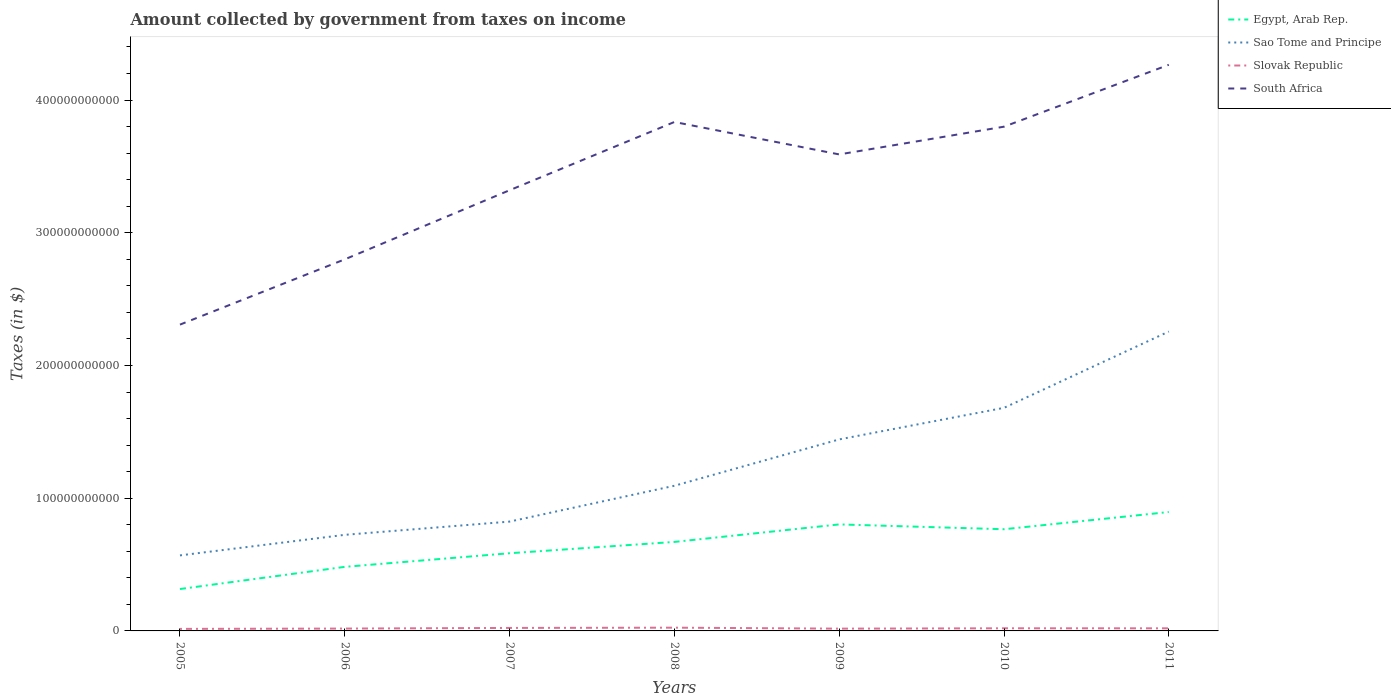Across all years, what is the maximum amount collected by government from taxes on income in South Africa?
Provide a succinct answer. 2.31e+11. In which year was the amount collected by government from taxes on income in Slovak Republic maximum?
Your answer should be compact. 2005. What is the total amount collected by government from taxes on income in South Africa in the graph?
Keep it short and to the point. -2.09e+1. What is the difference between the highest and the second highest amount collected by government from taxes on income in Egypt, Arab Rep.?
Your response must be concise. 5.80e+1. What is the difference between the highest and the lowest amount collected by government from taxes on income in Slovak Republic?
Offer a terse response. 4. Is the amount collected by government from taxes on income in Slovak Republic strictly greater than the amount collected by government from taxes on income in Sao Tome and Principe over the years?
Offer a terse response. Yes. How many lines are there?
Ensure brevity in your answer.  4. How many years are there in the graph?
Your answer should be very brief. 7. What is the difference between two consecutive major ticks on the Y-axis?
Offer a terse response. 1.00e+11. Are the values on the major ticks of Y-axis written in scientific E-notation?
Provide a short and direct response. No. Does the graph contain grids?
Your answer should be compact. No. Where does the legend appear in the graph?
Give a very brief answer. Top right. How many legend labels are there?
Your answer should be very brief. 4. How are the legend labels stacked?
Your answer should be very brief. Vertical. What is the title of the graph?
Offer a terse response. Amount collected by government from taxes on income. What is the label or title of the Y-axis?
Ensure brevity in your answer.  Taxes (in $). What is the Taxes (in $) of Egypt, Arab Rep. in 2005?
Offer a terse response. 3.16e+1. What is the Taxes (in $) of Sao Tome and Principe in 2005?
Your answer should be very brief. 5.69e+1. What is the Taxes (in $) of Slovak Republic in 2005?
Keep it short and to the point. 1.54e+09. What is the Taxes (in $) of South Africa in 2005?
Your answer should be compact. 2.31e+11. What is the Taxes (in $) of Egypt, Arab Rep. in 2006?
Offer a terse response. 4.83e+1. What is the Taxes (in $) in Sao Tome and Principe in 2006?
Keep it short and to the point. 7.24e+1. What is the Taxes (in $) of Slovak Republic in 2006?
Provide a succinct answer. 1.77e+09. What is the Taxes (in $) of South Africa in 2006?
Give a very brief answer. 2.80e+11. What is the Taxes (in $) in Egypt, Arab Rep. in 2007?
Your response must be concise. 5.85e+1. What is the Taxes (in $) in Sao Tome and Principe in 2007?
Offer a terse response. 8.24e+1. What is the Taxes (in $) in Slovak Republic in 2007?
Your answer should be compact. 2.25e+09. What is the Taxes (in $) of South Africa in 2007?
Provide a succinct answer. 3.32e+11. What is the Taxes (in $) of Egypt, Arab Rep. in 2008?
Your response must be concise. 6.71e+1. What is the Taxes (in $) of Sao Tome and Principe in 2008?
Give a very brief answer. 1.09e+11. What is the Taxes (in $) of Slovak Republic in 2008?
Your answer should be very brief. 2.46e+09. What is the Taxes (in $) in South Africa in 2008?
Provide a succinct answer. 3.83e+11. What is the Taxes (in $) in Egypt, Arab Rep. in 2009?
Offer a very short reply. 8.03e+1. What is the Taxes (in $) in Sao Tome and Principe in 2009?
Ensure brevity in your answer.  1.44e+11. What is the Taxes (in $) of Slovak Republic in 2009?
Provide a short and direct response. 1.71e+09. What is the Taxes (in $) of South Africa in 2009?
Provide a succinct answer. 3.59e+11. What is the Taxes (in $) in Egypt, Arab Rep. in 2010?
Offer a very short reply. 7.66e+1. What is the Taxes (in $) of Sao Tome and Principe in 2010?
Provide a short and direct response. 1.68e+11. What is the Taxes (in $) in Slovak Republic in 2010?
Give a very brief answer. 1.99e+09. What is the Taxes (in $) of South Africa in 2010?
Offer a very short reply. 3.80e+11. What is the Taxes (in $) in Egypt, Arab Rep. in 2011?
Your answer should be very brief. 8.96e+1. What is the Taxes (in $) of Sao Tome and Principe in 2011?
Offer a very short reply. 2.26e+11. What is the Taxes (in $) in Slovak Republic in 2011?
Make the answer very short. 1.96e+09. What is the Taxes (in $) in South Africa in 2011?
Keep it short and to the point. 4.27e+11. Across all years, what is the maximum Taxes (in $) in Egypt, Arab Rep.?
Provide a short and direct response. 8.96e+1. Across all years, what is the maximum Taxes (in $) of Sao Tome and Principe?
Offer a terse response. 2.26e+11. Across all years, what is the maximum Taxes (in $) of Slovak Republic?
Provide a short and direct response. 2.46e+09. Across all years, what is the maximum Taxes (in $) of South Africa?
Offer a terse response. 4.27e+11. Across all years, what is the minimum Taxes (in $) in Egypt, Arab Rep.?
Make the answer very short. 3.16e+1. Across all years, what is the minimum Taxes (in $) in Sao Tome and Principe?
Your answer should be compact. 5.69e+1. Across all years, what is the minimum Taxes (in $) of Slovak Republic?
Offer a terse response. 1.54e+09. Across all years, what is the minimum Taxes (in $) in South Africa?
Make the answer very short. 2.31e+11. What is the total Taxes (in $) of Egypt, Arab Rep. in the graph?
Offer a very short reply. 4.52e+11. What is the total Taxes (in $) of Sao Tome and Principe in the graph?
Provide a succinct answer. 8.59e+11. What is the total Taxes (in $) in Slovak Republic in the graph?
Your answer should be compact. 1.37e+1. What is the total Taxes (in $) in South Africa in the graph?
Keep it short and to the point. 2.39e+12. What is the difference between the Taxes (in $) of Egypt, Arab Rep. in 2005 and that in 2006?
Your answer should be compact. -1.67e+1. What is the difference between the Taxes (in $) in Sao Tome and Principe in 2005 and that in 2006?
Provide a succinct answer. -1.55e+1. What is the difference between the Taxes (in $) of Slovak Republic in 2005 and that in 2006?
Offer a terse response. -2.36e+08. What is the difference between the Taxes (in $) of South Africa in 2005 and that in 2006?
Your answer should be very brief. -4.92e+1. What is the difference between the Taxes (in $) in Egypt, Arab Rep. in 2005 and that in 2007?
Give a very brief answer. -2.70e+1. What is the difference between the Taxes (in $) of Sao Tome and Principe in 2005 and that in 2007?
Your response must be concise. -2.55e+1. What is the difference between the Taxes (in $) in Slovak Republic in 2005 and that in 2007?
Provide a succinct answer. -7.17e+08. What is the difference between the Taxes (in $) of South Africa in 2005 and that in 2007?
Keep it short and to the point. -1.01e+11. What is the difference between the Taxes (in $) in Egypt, Arab Rep. in 2005 and that in 2008?
Provide a short and direct response. -3.55e+1. What is the difference between the Taxes (in $) in Sao Tome and Principe in 2005 and that in 2008?
Provide a succinct answer. -5.25e+1. What is the difference between the Taxes (in $) in Slovak Republic in 2005 and that in 2008?
Your answer should be compact. -9.21e+08. What is the difference between the Taxes (in $) of South Africa in 2005 and that in 2008?
Ensure brevity in your answer.  -1.53e+11. What is the difference between the Taxes (in $) in Egypt, Arab Rep. in 2005 and that in 2009?
Provide a succinct answer. -4.87e+1. What is the difference between the Taxes (in $) of Sao Tome and Principe in 2005 and that in 2009?
Ensure brevity in your answer.  -8.74e+1. What is the difference between the Taxes (in $) in Slovak Republic in 2005 and that in 2009?
Provide a short and direct response. -1.77e+08. What is the difference between the Taxes (in $) in South Africa in 2005 and that in 2009?
Keep it short and to the point. -1.28e+11. What is the difference between the Taxes (in $) in Egypt, Arab Rep. in 2005 and that in 2010?
Make the answer very short. -4.50e+1. What is the difference between the Taxes (in $) in Sao Tome and Principe in 2005 and that in 2010?
Offer a very short reply. -1.11e+11. What is the difference between the Taxes (in $) of Slovak Republic in 2005 and that in 2010?
Your answer should be very brief. -4.52e+08. What is the difference between the Taxes (in $) of South Africa in 2005 and that in 2010?
Offer a very short reply. -1.49e+11. What is the difference between the Taxes (in $) in Egypt, Arab Rep. in 2005 and that in 2011?
Keep it short and to the point. -5.80e+1. What is the difference between the Taxes (in $) of Sao Tome and Principe in 2005 and that in 2011?
Keep it short and to the point. -1.69e+11. What is the difference between the Taxes (in $) in Slovak Republic in 2005 and that in 2011?
Keep it short and to the point. -4.30e+08. What is the difference between the Taxes (in $) in South Africa in 2005 and that in 2011?
Give a very brief answer. -1.96e+11. What is the difference between the Taxes (in $) in Egypt, Arab Rep. in 2006 and that in 2007?
Your response must be concise. -1.03e+1. What is the difference between the Taxes (in $) of Sao Tome and Principe in 2006 and that in 2007?
Provide a succinct answer. -9.97e+09. What is the difference between the Taxes (in $) in Slovak Republic in 2006 and that in 2007?
Your answer should be very brief. -4.82e+08. What is the difference between the Taxes (in $) of South Africa in 2006 and that in 2007?
Provide a short and direct response. -5.21e+1. What is the difference between the Taxes (in $) in Egypt, Arab Rep. in 2006 and that in 2008?
Your answer should be very brief. -1.88e+1. What is the difference between the Taxes (in $) in Sao Tome and Principe in 2006 and that in 2008?
Ensure brevity in your answer.  -3.70e+1. What is the difference between the Taxes (in $) in Slovak Republic in 2006 and that in 2008?
Your answer should be compact. -6.86e+08. What is the difference between the Taxes (in $) in South Africa in 2006 and that in 2008?
Your answer should be very brief. -1.03e+11. What is the difference between the Taxes (in $) in Egypt, Arab Rep. in 2006 and that in 2009?
Provide a short and direct response. -3.20e+1. What is the difference between the Taxes (in $) in Sao Tome and Principe in 2006 and that in 2009?
Provide a short and direct response. -7.19e+1. What is the difference between the Taxes (in $) in Slovak Republic in 2006 and that in 2009?
Your answer should be very brief. 5.84e+07. What is the difference between the Taxes (in $) in South Africa in 2006 and that in 2009?
Ensure brevity in your answer.  -7.91e+1. What is the difference between the Taxes (in $) of Egypt, Arab Rep. in 2006 and that in 2010?
Your answer should be very brief. -2.83e+1. What is the difference between the Taxes (in $) in Sao Tome and Principe in 2006 and that in 2010?
Provide a short and direct response. -9.57e+1. What is the difference between the Taxes (in $) of Slovak Republic in 2006 and that in 2010?
Make the answer very short. -2.16e+08. What is the difference between the Taxes (in $) of South Africa in 2006 and that in 2010?
Your response must be concise. -1.00e+11. What is the difference between the Taxes (in $) of Egypt, Arab Rep. in 2006 and that in 2011?
Your response must be concise. -4.13e+1. What is the difference between the Taxes (in $) in Sao Tome and Principe in 2006 and that in 2011?
Your answer should be very brief. -1.53e+11. What is the difference between the Taxes (in $) in Slovak Republic in 2006 and that in 2011?
Give a very brief answer. -1.94e+08. What is the difference between the Taxes (in $) in South Africa in 2006 and that in 2011?
Your answer should be very brief. -1.47e+11. What is the difference between the Taxes (in $) in Egypt, Arab Rep. in 2007 and that in 2008?
Your answer should be very brief. -8.52e+09. What is the difference between the Taxes (in $) of Sao Tome and Principe in 2007 and that in 2008?
Keep it short and to the point. -2.70e+1. What is the difference between the Taxes (in $) of Slovak Republic in 2007 and that in 2008?
Your response must be concise. -2.04e+08. What is the difference between the Taxes (in $) of South Africa in 2007 and that in 2008?
Ensure brevity in your answer.  -5.14e+1. What is the difference between the Taxes (in $) of Egypt, Arab Rep. in 2007 and that in 2009?
Your response must be concise. -2.17e+1. What is the difference between the Taxes (in $) in Sao Tome and Principe in 2007 and that in 2009?
Give a very brief answer. -6.19e+1. What is the difference between the Taxes (in $) in Slovak Republic in 2007 and that in 2009?
Your response must be concise. 5.40e+08. What is the difference between the Taxes (in $) in South Africa in 2007 and that in 2009?
Keep it short and to the point. -2.70e+1. What is the difference between the Taxes (in $) in Egypt, Arab Rep. in 2007 and that in 2010?
Give a very brief answer. -1.81e+1. What is the difference between the Taxes (in $) of Sao Tome and Principe in 2007 and that in 2010?
Offer a terse response. -8.57e+1. What is the difference between the Taxes (in $) in Slovak Republic in 2007 and that in 2010?
Your response must be concise. 2.66e+08. What is the difference between the Taxes (in $) in South Africa in 2007 and that in 2010?
Provide a succinct answer. -4.79e+1. What is the difference between the Taxes (in $) in Egypt, Arab Rep. in 2007 and that in 2011?
Give a very brief answer. -3.11e+1. What is the difference between the Taxes (in $) of Sao Tome and Principe in 2007 and that in 2011?
Your answer should be very brief. -1.43e+11. What is the difference between the Taxes (in $) in Slovak Republic in 2007 and that in 2011?
Your answer should be compact. 2.87e+08. What is the difference between the Taxes (in $) in South Africa in 2007 and that in 2011?
Provide a succinct answer. -9.45e+1. What is the difference between the Taxes (in $) of Egypt, Arab Rep. in 2008 and that in 2009?
Your response must be concise. -1.32e+1. What is the difference between the Taxes (in $) in Sao Tome and Principe in 2008 and that in 2009?
Your answer should be very brief. -3.49e+1. What is the difference between the Taxes (in $) in Slovak Republic in 2008 and that in 2009?
Your answer should be very brief. 7.44e+08. What is the difference between the Taxes (in $) in South Africa in 2008 and that in 2009?
Provide a short and direct response. 2.44e+1. What is the difference between the Taxes (in $) in Egypt, Arab Rep. in 2008 and that in 2010?
Offer a terse response. -9.56e+09. What is the difference between the Taxes (in $) in Sao Tome and Principe in 2008 and that in 2010?
Your answer should be very brief. -5.87e+1. What is the difference between the Taxes (in $) of Slovak Republic in 2008 and that in 2010?
Your answer should be very brief. 4.70e+08. What is the difference between the Taxes (in $) in South Africa in 2008 and that in 2010?
Offer a very short reply. 3.54e+09. What is the difference between the Taxes (in $) in Egypt, Arab Rep. in 2008 and that in 2011?
Offer a terse response. -2.25e+1. What is the difference between the Taxes (in $) in Sao Tome and Principe in 2008 and that in 2011?
Offer a terse response. -1.16e+11. What is the difference between the Taxes (in $) in Slovak Republic in 2008 and that in 2011?
Offer a terse response. 4.91e+08. What is the difference between the Taxes (in $) of South Africa in 2008 and that in 2011?
Your answer should be compact. -4.31e+1. What is the difference between the Taxes (in $) of Egypt, Arab Rep. in 2009 and that in 2010?
Keep it short and to the point. 3.64e+09. What is the difference between the Taxes (in $) in Sao Tome and Principe in 2009 and that in 2010?
Your response must be concise. -2.38e+1. What is the difference between the Taxes (in $) of Slovak Republic in 2009 and that in 2010?
Make the answer very short. -2.74e+08. What is the difference between the Taxes (in $) of South Africa in 2009 and that in 2010?
Your answer should be very brief. -2.09e+1. What is the difference between the Taxes (in $) in Egypt, Arab Rep. in 2009 and that in 2011?
Make the answer very short. -9.34e+09. What is the difference between the Taxes (in $) in Sao Tome and Principe in 2009 and that in 2011?
Your response must be concise. -8.13e+1. What is the difference between the Taxes (in $) of Slovak Republic in 2009 and that in 2011?
Keep it short and to the point. -2.53e+08. What is the difference between the Taxes (in $) in South Africa in 2009 and that in 2011?
Keep it short and to the point. -6.75e+1. What is the difference between the Taxes (in $) in Egypt, Arab Rep. in 2010 and that in 2011?
Make the answer very short. -1.30e+1. What is the difference between the Taxes (in $) in Sao Tome and Principe in 2010 and that in 2011?
Provide a short and direct response. -5.75e+1. What is the difference between the Taxes (in $) in Slovak Republic in 2010 and that in 2011?
Offer a very short reply. 2.17e+07. What is the difference between the Taxes (in $) of South Africa in 2010 and that in 2011?
Provide a succinct answer. -4.66e+1. What is the difference between the Taxes (in $) of Egypt, Arab Rep. in 2005 and the Taxes (in $) of Sao Tome and Principe in 2006?
Give a very brief answer. -4.08e+1. What is the difference between the Taxes (in $) of Egypt, Arab Rep. in 2005 and the Taxes (in $) of Slovak Republic in 2006?
Make the answer very short. 2.98e+1. What is the difference between the Taxes (in $) of Egypt, Arab Rep. in 2005 and the Taxes (in $) of South Africa in 2006?
Offer a very short reply. -2.48e+11. What is the difference between the Taxes (in $) in Sao Tome and Principe in 2005 and the Taxes (in $) in Slovak Republic in 2006?
Provide a short and direct response. 5.51e+1. What is the difference between the Taxes (in $) of Sao Tome and Principe in 2005 and the Taxes (in $) of South Africa in 2006?
Offer a very short reply. -2.23e+11. What is the difference between the Taxes (in $) in Slovak Republic in 2005 and the Taxes (in $) in South Africa in 2006?
Offer a terse response. -2.78e+11. What is the difference between the Taxes (in $) in Egypt, Arab Rep. in 2005 and the Taxes (in $) in Sao Tome and Principe in 2007?
Provide a short and direct response. -5.08e+1. What is the difference between the Taxes (in $) of Egypt, Arab Rep. in 2005 and the Taxes (in $) of Slovak Republic in 2007?
Keep it short and to the point. 2.93e+1. What is the difference between the Taxes (in $) of Egypt, Arab Rep. in 2005 and the Taxes (in $) of South Africa in 2007?
Make the answer very short. -3.00e+11. What is the difference between the Taxes (in $) in Sao Tome and Principe in 2005 and the Taxes (in $) in Slovak Republic in 2007?
Ensure brevity in your answer.  5.47e+1. What is the difference between the Taxes (in $) in Sao Tome and Principe in 2005 and the Taxes (in $) in South Africa in 2007?
Your answer should be compact. -2.75e+11. What is the difference between the Taxes (in $) of Slovak Republic in 2005 and the Taxes (in $) of South Africa in 2007?
Provide a short and direct response. -3.31e+11. What is the difference between the Taxes (in $) in Egypt, Arab Rep. in 2005 and the Taxes (in $) in Sao Tome and Principe in 2008?
Give a very brief answer. -7.78e+1. What is the difference between the Taxes (in $) of Egypt, Arab Rep. in 2005 and the Taxes (in $) of Slovak Republic in 2008?
Your answer should be very brief. 2.91e+1. What is the difference between the Taxes (in $) in Egypt, Arab Rep. in 2005 and the Taxes (in $) in South Africa in 2008?
Your answer should be very brief. -3.52e+11. What is the difference between the Taxes (in $) of Sao Tome and Principe in 2005 and the Taxes (in $) of Slovak Republic in 2008?
Provide a succinct answer. 5.45e+1. What is the difference between the Taxes (in $) of Sao Tome and Principe in 2005 and the Taxes (in $) of South Africa in 2008?
Offer a terse response. -3.27e+11. What is the difference between the Taxes (in $) of Slovak Republic in 2005 and the Taxes (in $) of South Africa in 2008?
Offer a very short reply. -3.82e+11. What is the difference between the Taxes (in $) of Egypt, Arab Rep. in 2005 and the Taxes (in $) of Sao Tome and Principe in 2009?
Ensure brevity in your answer.  -1.13e+11. What is the difference between the Taxes (in $) of Egypt, Arab Rep. in 2005 and the Taxes (in $) of Slovak Republic in 2009?
Give a very brief answer. 2.99e+1. What is the difference between the Taxes (in $) of Egypt, Arab Rep. in 2005 and the Taxes (in $) of South Africa in 2009?
Your answer should be very brief. -3.27e+11. What is the difference between the Taxes (in $) in Sao Tome and Principe in 2005 and the Taxes (in $) in Slovak Republic in 2009?
Your answer should be very brief. 5.52e+1. What is the difference between the Taxes (in $) of Sao Tome and Principe in 2005 and the Taxes (in $) of South Africa in 2009?
Make the answer very short. -3.02e+11. What is the difference between the Taxes (in $) in Slovak Republic in 2005 and the Taxes (in $) in South Africa in 2009?
Ensure brevity in your answer.  -3.58e+11. What is the difference between the Taxes (in $) of Egypt, Arab Rep. in 2005 and the Taxes (in $) of Sao Tome and Principe in 2010?
Provide a succinct answer. -1.37e+11. What is the difference between the Taxes (in $) in Egypt, Arab Rep. in 2005 and the Taxes (in $) in Slovak Republic in 2010?
Offer a very short reply. 2.96e+1. What is the difference between the Taxes (in $) of Egypt, Arab Rep. in 2005 and the Taxes (in $) of South Africa in 2010?
Your answer should be very brief. -3.48e+11. What is the difference between the Taxes (in $) of Sao Tome and Principe in 2005 and the Taxes (in $) of Slovak Republic in 2010?
Keep it short and to the point. 5.49e+1. What is the difference between the Taxes (in $) of Sao Tome and Principe in 2005 and the Taxes (in $) of South Africa in 2010?
Provide a succinct answer. -3.23e+11. What is the difference between the Taxes (in $) of Slovak Republic in 2005 and the Taxes (in $) of South Africa in 2010?
Your answer should be compact. -3.78e+11. What is the difference between the Taxes (in $) in Egypt, Arab Rep. in 2005 and the Taxes (in $) in Sao Tome and Principe in 2011?
Provide a succinct answer. -1.94e+11. What is the difference between the Taxes (in $) in Egypt, Arab Rep. in 2005 and the Taxes (in $) in Slovak Republic in 2011?
Your response must be concise. 2.96e+1. What is the difference between the Taxes (in $) in Egypt, Arab Rep. in 2005 and the Taxes (in $) in South Africa in 2011?
Your answer should be compact. -3.95e+11. What is the difference between the Taxes (in $) of Sao Tome and Principe in 2005 and the Taxes (in $) of Slovak Republic in 2011?
Provide a succinct answer. 5.49e+1. What is the difference between the Taxes (in $) of Sao Tome and Principe in 2005 and the Taxes (in $) of South Africa in 2011?
Provide a short and direct response. -3.70e+11. What is the difference between the Taxes (in $) of Slovak Republic in 2005 and the Taxes (in $) of South Africa in 2011?
Give a very brief answer. -4.25e+11. What is the difference between the Taxes (in $) of Egypt, Arab Rep. in 2006 and the Taxes (in $) of Sao Tome and Principe in 2007?
Make the answer very short. -3.41e+1. What is the difference between the Taxes (in $) of Egypt, Arab Rep. in 2006 and the Taxes (in $) of Slovak Republic in 2007?
Offer a terse response. 4.60e+1. What is the difference between the Taxes (in $) in Egypt, Arab Rep. in 2006 and the Taxes (in $) in South Africa in 2007?
Offer a very short reply. -2.84e+11. What is the difference between the Taxes (in $) in Sao Tome and Principe in 2006 and the Taxes (in $) in Slovak Republic in 2007?
Your answer should be very brief. 7.01e+1. What is the difference between the Taxes (in $) in Sao Tome and Principe in 2006 and the Taxes (in $) in South Africa in 2007?
Your answer should be compact. -2.60e+11. What is the difference between the Taxes (in $) of Slovak Republic in 2006 and the Taxes (in $) of South Africa in 2007?
Offer a very short reply. -3.30e+11. What is the difference between the Taxes (in $) of Egypt, Arab Rep. in 2006 and the Taxes (in $) of Sao Tome and Principe in 2008?
Make the answer very short. -6.11e+1. What is the difference between the Taxes (in $) of Egypt, Arab Rep. in 2006 and the Taxes (in $) of Slovak Republic in 2008?
Give a very brief answer. 4.58e+1. What is the difference between the Taxes (in $) in Egypt, Arab Rep. in 2006 and the Taxes (in $) in South Africa in 2008?
Your answer should be compact. -3.35e+11. What is the difference between the Taxes (in $) in Sao Tome and Principe in 2006 and the Taxes (in $) in Slovak Republic in 2008?
Offer a terse response. 6.99e+1. What is the difference between the Taxes (in $) in Sao Tome and Principe in 2006 and the Taxes (in $) in South Africa in 2008?
Keep it short and to the point. -3.11e+11. What is the difference between the Taxes (in $) of Slovak Republic in 2006 and the Taxes (in $) of South Africa in 2008?
Your answer should be compact. -3.82e+11. What is the difference between the Taxes (in $) of Egypt, Arab Rep. in 2006 and the Taxes (in $) of Sao Tome and Principe in 2009?
Offer a terse response. -9.60e+1. What is the difference between the Taxes (in $) in Egypt, Arab Rep. in 2006 and the Taxes (in $) in Slovak Republic in 2009?
Make the answer very short. 4.66e+1. What is the difference between the Taxes (in $) in Egypt, Arab Rep. in 2006 and the Taxes (in $) in South Africa in 2009?
Your answer should be very brief. -3.11e+11. What is the difference between the Taxes (in $) of Sao Tome and Principe in 2006 and the Taxes (in $) of Slovak Republic in 2009?
Make the answer very short. 7.07e+1. What is the difference between the Taxes (in $) of Sao Tome and Principe in 2006 and the Taxes (in $) of South Africa in 2009?
Offer a very short reply. -2.87e+11. What is the difference between the Taxes (in $) of Slovak Republic in 2006 and the Taxes (in $) of South Africa in 2009?
Your answer should be very brief. -3.57e+11. What is the difference between the Taxes (in $) in Egypt, Arab Rep. in 2006 and the Taxes (in $) in Sao Tome and Principe in 2010?
Your response must be concise. -1.20e+11. What is the difference between the Taxes (in $) of Egypt, Arab Rep. in 2006 and the Taxes (in $) of Slovak Republic in 2010?
Provide a succinct answer. 4.63e+1. What is the difference between the Taxes (in $) of Egypt, Arab Rep. in 2006 and the Taxes (in $) of South Africa in 2010?
Give a very brief answer. -3.32e+11. What is the difference between the Taxes (in $) of Sao Tome and Principe in 2006 and the Taxes (in $) of Slovak Republic in 2010?
Offer a very short reply. 7.04e+1. What is the difference between the Taxes (in $) in Sao Tome and Principe in 2006 and the Taxes (in $) in South Africa in 2010?
Provide a succinct answer. -3.08e+11. What is the difference between the Taxes (in $) in Slovak Republic in 2006 and the Taxes (in $) in South Africa in 2010?
Offer a very short reply. -3.78e+11. What is the difference between the Taxes (in $) in Egypt, Arab Rep. in 2006 and the Taxes (in $) in Sao Tome and Principe in 2011?
Offer a terse response. -1.77e+11. What is the difference between the Taxes (in $) of Egypt, Arab Rep. in 2006 and the Taxes (in $) of Slovak Republic in 2011?
Keep it short and to the point. 4.63e+1. What is the difference between the Taxes (in $) of Egypt, Arab Rep. in 2006 and the Taxes (in $) of South Africa in 2011?
Your answer should be very brief. -3.78e+11. What is the difference between the Taxes (in $) of Sao Tome and Principe in 2006 and the Taxes (in $) of Slovak Republic in 2011?
Provide a short and direct response. 7.04e+1. What is the difference between the Taxes (in $) in Sao Tome and Principe in 2006 and the Taxes (in $) in South Africa in 2011?
Ensure brevity in your answer.  -3.54e+11. What is the difference between the Taxes (in $) in Slovak Republic in 2006 and the Taxes (in $) in South Africa in 2011?
Offer a very short reply. -4.25e+11. What is the difference between the Taxes (in $) in Egypt, Arab Rep. in 2007 and the Taxes (in $) in Sao Tome and Principe in 2008?
Your answer should be compact. -5.08e+1. What is the difference between the Taxes (in $) in Egypt, Arab Rep. in 2007 and the Taxes (in $) in Slovak Republic in 2008?
Offer a terse response. 5.61e+1. What is the difference between the Taxes (in $) in Egypt, Arab Rep. in 2007 and the Taxes (in $) in South Africa in 2008?
Provide a succinct answer. -3.25e+11. What is the difference between the Taxes (in $) of Sao Tome and Principe in 2007 and the Taxes (in $) of Slovak Republic in 2008?
Your response must be concise. 7.99e+1. What is the difference between the Taxes (in $) in Sao Tome and Principe in 2007 and the Taxes (in $) in South Africa in 2008?
Offer a terse response. -3.01e+11. What is the difference between the Taxes (in $) of Slovak Republic in 2007 and the Taxes (in $) of South Africa in 2008?
Your response must be concise. -3.81e+11. What is the difference between the Taxes (in $) in Egypt, Arab Rep. in 2007 and the Taxes (in $) in Sao Tome and Principe in 2009?
Provide a short and direct response. -8.58e+1. What is the difference between the Taxes (in $) of Egypt, Arab Rep. in 2007 and the Taxes (in $) of Slovak Republic in 2009?
Give a very brief answer. 5.68e+1. What is the difference between the Taxes (in $) of Egypt, Arab Rep. in 2007 and the Taxes (in $) of South Africa in 2009?
Keep it short and to the point. -3.01e+11. What is the difference between the Taxes (in $) in Sao Tome and Principe in 2007 and the Taxes (in $) in Slovak Republic in 2009?
Your answer should be compact. 8.07e+1. What is the difference between the Taxes (in $) in Sao Tome and Principe in 2007 and the Taxes (in $) in South Africa in 2009?
Give a very brief answer. -2.77e+11. What is the difference between the Taxes (in $) in Slovak Republic in 2007 and the Taxes (in $) in South Africa in 2009?
Provide a succinct answer. -3.57e+11. What is the difference between the Taxes (in $) of Egypt, Arab Rep. in 2007 and the Taxes (in $) of Sao Tome and Principe in 2010?
Your answer should be compact. -1.10e+11. What is the difference between the Taxes (in $) of Egypt, Arab Rep. in 2007 and the Taxes (in $) of Slovak Republic in 2010?
Your answer should be very brief. 5.65e+1. What is the difference between the Taxes (in $) of Egypt, Arab Rep. in 2007 and the Taxes (in $) of South Africa in 2010?
Make the answer very short. -3.21e+11. What is the difference between the Taxes (in $) of Sao Tome and Principe in 2007 and the Taxes (in $) of Slovak Republic in 2010?
Offer a terse response. 8.04e+1. What is the difference between the Taxes (in $) in Sao Tome and Principe in 2007 and the Taxes (in $) in South Africa in 2010?
Your answer should be very brief. -2.98e+11. What is the difference between the Taxes (in $) of Slovak Republic in 2007 and the Taxes (in $) of South Africa in 2010?
Provide a short and direct response. -3.78e+11. What is the difference between the Taxes (in $) of Egypt, Arab Rep. in 2007 and the Taxes (in $) of Sao Tome and Principe in 2011?
Make the answer very short. -1.67e+11. What is the difference between the Taxes (in $) of Egypt, Arab Rep. in 2007 and the Taxes (in $) of Slovak Republic in 2011?
Provide a short and direct response. 5.66e+1. What is the difference between the Taxes (in $) of Egypt, Arab Rep. in 2007 and the Taxes (in $) of South Africa in 2011?
Offer a very short reply. -3.68e+11. What is the difference between the Taxes (in $) in Sao Tome and Principe in 2007 and the Taxes (in $) in Slovak Republic in 2011?
Your response must be concise. 8.04e+1. What is the difference between the Taxes (in $) in Sao Tome and Principe in 2007 and the Taxes (in $) in South Africa in 2011?
Your response must be concise. -3.44e+11. What is the difference between the Taxes (in $) of Slovak Republic in 2007 and the Taxes (in $) of South Africa in 2011?
Your answer should be very brief. -4.24e+11. What is the difference between the Taxes (in $) of Egypt, Arab Rep. in 2008 and the Taxes (in $) of Sao Tome and Principe in 2009?
Provide a succinct answer. -7.73e+1. What is the difference between the Taxes (in $) of Egypt, Arab Rep. in 2008 and the Taxes (in $) of Slovak Republic in 2009?
Ensure brevity in your answer.  6.53e+1. What is the difference between the Taxes (in $) in Egypt, Arab Rep. in 2008 and the Taxes (in $) in South Africa in 2009?
Ensure brevity in your answer.  -2.92e+11. What is the difference between the Taxes (in $) in Sao Tome and Principe in 2008 and the Taxes (in $) in Slovak Republic in 2009?
Give a very brief answer. 1.08e+11. What is the difference between the Taxes (in $) in Sao Tome and Principe in 2008 and the Taxes (in $) in South Africa in 2009?
Make the answer very short. -2.50e+11. What is the difference between the Taxes (in $) of Slovak Republic in 2008 and the Taxes (in $) of South Africa in 2009?
Keep it short and to the point. -3.57e+11. What is the difference between the Taxes (in $) in Egypt, Arab Rep. in 2008 and the Taxes (in $) in Sao Tome and Principe in 2010?
Give a very brief answer. -1.01e+11. What is the difference between the Taxes (in $) in Egypt, Arab Rep. in 2008 and the Taxes (in $) in Slovak Republic in 2010?
Offer a terse response. 6.51e+1. What is the difference between the Taxes (in $) in Egypt, Arab Rep. in 2008 and the Taxes (in $) in South Africa in 2010?
Make the answer very short. -3.13e+11. What is the difference between the Taxes (in $) of Sao Tome and Principe in 2008 and the Taxes (in $) of Slovak Republic in 2010?
Make the answer very short. 1.07e+11. What is the difference between the Taxes (in $) in Sao Tome and Principe in 2008 and the Taxes (in $) in South Africa in 2010?
Ensure brevity in your answer.  -2.71e+11. What is the difference between the Taxes (in $) in Slovak Republic in 2008 and the Taxes (in $) in South Africa in 2010?
Provide a short and direct response. -3.77e+11. What is the difference between the Taxes (in $) in Egypt, Arab Rep. in 2008 and the Taxes (in $) in Sao Tome and Principe in 2011?
Offer a terse response. -1.59e+11. What is the difference between the Taxes (in $) in Egypt, Arab Rep. in 2008 and the Taxes (in $) in Slovak Republic in 2011?
Keep it short and to the point. 6.51e+1. What is the difference between the Taxes (in $) of Egypt, Arab Rep. in 2008 and the Taxes (in $) of South Africa in 2011?
Your answer should be compact. -3.60e+11. What is the difference between the Taxes (in $) in Sao Tome and Principe in 2008 and the Taxes (in $) in Slovak Republic in 2011?
Provide a short and direct response. 1.07e+11. What is the difference between the Taxes (in $) in Sao Tome and Principe in 2008 and the Taxes (in $) in South Africa in 2011?
Offer a very short reply. -3.17e+11. What is the difference between the Taxes (in $) of Slovak Republic in 2008 and the Taxes (in $) of South Africa in 2011?
Your response must be concise. -4.24e+11. What is the difference between the Taxes (in $) in Egypt, Arab Rep. in 2009 and the Taxes (in $) in Sao Tome and Principe in 2010?
Provide a short and direct response. -8.78e+1. What is the difference between the Taxes (in $) in Egypt, Arab Rep. in 2009 and the Taxes (in $) in Slovak Republic in 2010?
Offer a terse response. 7.83e+1. What is the difference between the Taxes (in $) in Egypt, Arab Rep. in 2009 and the Taxes (in $) in South Africa in 2010?
Offer a terse response. -3.00e+11. What is the difference between the Taxes (in $) of Sao Tome and Principe in 2009 and the Taxes (in $) of Slovak Republic in 2010?
Offer a very short reply. 1.42e+11. What is the difference between the Taxes (in $) in Sao Tome and Principe in 2009 and the Taxes (in $) in South Africa in 2010?
Offer a terse response. -2.36e+11. What is the difference between the Taxes (in $) of Slovak Republic in 2009 and the Taxes (in $) of South Africa in 2010?
Offer a very short reply. -3.78e+11. What is the difference between the Taxes (in $) of Egypt, Arab Rep. in 2009 and the Taxes (in $) of Sao Tome and Principe in 2011?
Your answer should be compact. -1.45e+11. What is the difference between the Taxes (in $) in Egypt, Arab Rep. in 2009 and the Taxes (in $) in Slovak Republic in 2011?
Your answer should be compact. 7.83e+1. What is the difference between the Taxes (in $) in Egypt, Arab Rep. in 2009 and the Taxes (in $) in South Africa in 2011?
Your response must be concise. -3.46e+11. What is the difference between the Taxes (in $) in Sao Tome and Principe in 2009 and the Taxes (in $) in Slovak Republic in 2011?
Your response must be concise. 1.42e+11. What is the difference between the Taxes (in $) of Sao Tome and Principe in 2009 and the Taxes (in $) of South Africa in 2011?
Offer a very short reply. -2.82e+11. What is the difference between the Taxes (in $) in Slovak Republic in 2009 and the Taxes (in $) in South Africa in 2011?
Your answer should be very brief. -4.25e+11. What is the difference between the Taxes (in $) in Egypt, Arab Rep. in 2010 and the Taxes (in $) in Sao Tome and Principe in 2011?
Provide a succinct answer. -1.49e+11. What is the difference between the Taxes (in $) in Egypt, Arab Rep. in 2010 and the Taxes (in $) in Slovak Republic in 2011?
Keep it short and to the point. 7.47e+1. What is the difference between the Taxes (in $) in Egypt, Arab Rep. in 2010 and the Taxes (in $) in South Africa in 2011?
Make the answer very short. -3.50e+11. What is the difference between the Taxes (in $) of Sao Tome and Principe in 2010 and the Taxes (in $) of Slovak Republic in 2011?
Your response must be concise. 1.66e+11. What is the difference between the Taxes (in $) of Sao Tome and Principe in 2010 and the Taxes (in $) of South Africa in 2011?
Offer a very short reply. -2.58e+11. What is the difference between the Taxes (in $) in Slovak Republic in 2010 and the Taxes (in $) in South Africa in 2011?
Your answer should be compact. -4.25e+11. What is the average Taxes (in $) of Egypt, Arab Rep. per year?
Make the answer very short. 6.46e+1. What is the average Taxes (in $) of Sao Tome and Principe per year?
Offer a terse response. 1.23e+11. What is the average Taxes (in $) of Slovak Republic per year?
Keep it short and to the point. 1.95e+09. What is the average Taxes (in $) of South Africa per year?
Offer a very short reply. 3.42e+11. In the year 2005, what is the difference between the Taxes (in $) in Egypt, Arab Rep. and Taxes (in $) in Sao Tome and Principe?
Your answer should be very brief. -2.53e+1. In the year 2005, what is the difference between the Taxes (in $) of Egypt, Arab Rep. and Taxes (in $) of Slovak Republic?
Offer a terse response. 3.00e+1. In the year 2005, what is the difference between the Taxes (in $) of Egypt, Arab Rep. and Taxes (in $) of South Africa?
Provide a short and direct response. -1.99e+11. In the year 2005, what is the difference between the Taxes (in $) of Sao Tome and Principe and Taxes (in $) of Slovak Republic?
Make the answer very short. 5.54e+1. In the year 2005, what is the difference between the Taxes (in $) of Sao Tome and Principe and Taxes (in $) of South Africa?
Your response must be concise. -1.74e+11. In the year 2005, what is the difference between the Taxes (in $) of Slovak Republic and Taxes (in $) of South Africa?
Offer a terse response. -2.29e+11. In the year 2006, what is the difference between the Taxes (in $) of Egypt, Arab Rep. and Taxes (in $) of Sao Tome and Principe?
Make the answer very short. -2.41e+1. In the year 2006, what is the difference between the Taxes (in $) of Egypt, Arab Rep. and Taxes (in $) of Slovak Republic?
Provide a succinct answer. 4.65e+1. In the year 2006, what is the difference between the Taxes (in $) of Egypt, Arab Rep. and Taxes (in $) of South Africa?
Keep it short and to the point. -2.32e+11. In the year 2006, what is the difference between the Taxes (in $) of Sao Tome and Principe and Taxes (in $) of Slovak Republic?
Offer a very short reply. 7.06e+1. In the year 2006, what is the difference between the Taxes (in $) of Sao Tome and Principe and Taxes (in $) of South Africa?
Keep it short and to the point. -2.08e+11. In the year 2006, what is the difference between the Taxes (in $) in Slovak Republic and Taxes (in $) in South Africa?
Ensure brevity in your answer.  -2.78e+11. In the year 2007, what is the difference between the Taxes (in $) in Egypt, Arab Rep. and Taxes (in $) in Sao Tome and Principe?
Make the answer very short. -2.38e+1. In the year 2007, what is the difference between the Taxes (in $) in Egypt, Arab Rep. and Taxes (in $) in Slovak Republic?
Offer a very short reply. 5.63e+1. In the year 2007, what is the difference between the Taxes (in $) in Egypt, Arab Rep. and Taxes (in $) in South Africa?
Give a very brief answer. -2.74e+11. In the year 2007, what is the difference between the Taxes (in $) in Sao Tome and Principe and Taxes (in $) in Slovak Republic?
Provide a short and direct response. 8.01e+1. In the year 2007, what is the difference between the Taxes (in $) in Sao Tome and Principe and Taxes (in $) in South Africa?
Provide a succinct answer. -2.50e+11. In the year 2007, what is the difference between the Taxes (in $) of Slovak Republic and Taxes (in $) of South Africa?
Give a very brief answer. -3.30e+11. In the year 2008, what is the difference between the Taxes (in $) of Egypt, Arab Rep. and Taxes (in $) of Sao Tome and Principe?
Provide a short and direct response. -4.23e+1. In the year 2008, what is the difference between the Taxes (in $) of Egypt, Arab Rep. and Taxes (in $) of Slovak Republic?
Provide a succinct answer. 6.46e+1. In the year 2008, what is the difference between the Taxes (in $) in Egypt, Arab Rep. and Taxes (in $) in South Africa?
Your answer should be compact. -3.16e+11. In the year 2008, what is the difference between the Taxes (in $) of Sao Tome and Principe and Taxes (in $) of Slovak Republic?
Keep it short and to the point. 1.07e+11. In the year 2008, what is the difference between the Taxes (in $) of Sao Tome and Principe and Taxes (in $) of South Africa?
Provide a short and direct response. -2.74e+11. In the year 2008, what is the difference between the Taxes (in $) of Slovak Republic and Taxes (in $) of South Africa?
Your response must be concise. -3.81e+11. In the year 2009, what is the difference between the Taxes (in $) in Egypt, Arab Rep. and Taxes (in $) in Sao Tome and Principe?
Give a very brief answer. -6.41e+1. In the year 2009, what is the difference between the Taxes (in $) in Egypt, Arab Rep. and Taxes (in $) in Slovak Republic?
Keep it short and to the point. 7.85e+1. In the year 2009, what is the difference between the Taxes (in $) in Egypt, Arab Rep. and Taxes (in $) in South Africa?
Your answer should be compact. -2.79e+11. In the year 2009, what is the difference between the Taxes (in $) of Sao Tome and Principe and Taxes (in $) of Slovak Republic?
Provide a short and direct response. 1.43e+11. In the year 2009, what is the difference between the Taxes (in $) of Sao Tome and Principe and Taxes (in $) of South Africa?
Your answer should be compact. -2.15e+11. In the year 2009, what is the difference between the Taxes (in $) in Slovak Republic and Taxes (in $) in South Africa?
Provide a succinct answer. -3.57e+11. In the year 2010, what is the difference between the Taxes (in $) of Egypt, Arab Rep. and Taxes (in $) of Sao Tome and Principe?
Give a very brief answer. -9.15e+1. In the year 2010, what is the difference between the Taxes (in $) in Egypt, Arab Rep. and Taxes (in $) in Slovak Republic?
Make the answer very short. 7.46e+1. In the year 2010, what is the difference between the Taxes (in $) of Egypt, Arab Rep. and Taxes (in $) of South Africa?
Make the answer very short. -3.03e+11. In the year 2010, what is the difference between the Taxes (in $) of Sao Tome and Principe and Taxes (in $) of Slovak Republic?
Give a very brief answer. 1.66e+11. In the year 2010, what is the difference between the Taxes (in $) of Sao Tome and Principe and Taxes (in $) of South Africa?
Provide a succinct answer. -2.12e+11. In the year 2010, what is the difference between the Taxes (in $) in Slovak Republic and Taxes (in $) in South Africa?
Ensure brevity in your answer.  -3.78e+11. In the year 2011, what is the difference between the Taxes (in $) of Egypt, Arab Rep. and Taxes (in $) of Sao Tome and Principe?
Offer a terse response. -1.36e+11. In the year 2011, what is the difference between the Taxes (in $) of Egypt, Arab Rep. and Taxes (in $) of Slovak Republic?
Offer a very short reply. 8.76e+1. In the year 2011, what is the difference between the Taxes (in $) in Egypt, Arab Rep. and Taxes (in $) in South Africa?
Give a very brief answer. -3.37e+11. In the year 2011, what is the difference between the Taxes (in $) in Sao Tome and Principe and Taxes (in $) in Slovak Republic?
Your answer should be very brief. 2.24e+11. In the year 2011, what is the difference between the Taxes (in $) of Sao Tome and Principe and Taxes (in $) of South Africa?
Make the answer very short. -2.01e+11. In the year 2011, what is the difference between the Taxes (in $) of Slovak Republic and Taxes (in $) of South Africa?
Make the answer very short. -4.25e+11. What is the ratio of the Taxes (in $) in Egypt, Arab Rep. in 2005 to that in 2006?
Your answer should be very brief. 0.65. What is the ratio of the Taxes (in $) of Sao Tome and Principe in 2005 to that in 2006?
Provide a short and direct response. 0.79. What is the ratio of the Taxes (in $) in Slovak Republic in 2005 to that in 2006?
Keep it short and to the point. 0.87. What is the ratio of the Taxes (in $) of South Africa in 2005 to that in 2006?
Ensure brevity in your answer.  0.82. What is the ratio of the Taxes (in $) in Egypt, Arab Rep. in 2005 to that in 2007?
Keep it short and to the point. 0.54. What is the ratio of the Taxes (in $) in Sao Tome and Principe in 2005 to that in 2007?
Provide a succinct answer. 0.69. What is the ratio of the Taxes (in $) of Slovak Republic in 2005 to that in 2007?
Provide a succinct answer. 0.68. What is the ratio of the Taxes (in $) in South Africa in 2005 to that in 2007?
Give a very brief answer. 0.7. What is the ratio of the Taxes (in $) of Egypt, Arab Rep. in 2005 to that in 2008?
Your answer should be compact. 0.47. What is the ratio of the Taxes (in $) in Sao Tome and Principe in 2005 to that in 2008?
Your answer should be very brief. 0.52. What is the ratio of the Taxes (in $) of Slovak Republic in 2005 to that in 2008?
Your answer should be very brief. 0.62. What is the ratio of the Taxes (in $) in South Africa in 2005 to that in 2008?
Your answer should be compact. 0.6. What is the ratio of the Taxes (in $) in Egypt, Arab Rep. in 2005 to that in 2009?
Offer a terse response. 0.39. What is the ratio of the Taxes (in $) of Sao Tome and Principe in 2005 to that in 2009?
Ensure brevity in your answer.  0.39. What is the ratio of the Taxes (in $) of Slovak Republic in 2005 to that in 2009?
Offer a terse response. 0.9. What is the ratio of the Taxes (in $) of South Africa in 2005 to that in 2009?
Provide a succinct answer. 0.64. What is the ratio of the Taxes (in $) in Egypt, Arab Rep. in 2005 to that in 2010?
Your response must be concise. 0.41. What is the ratio of the Taxes (in $) of Sao Tome and Principe in 2005 to that in 2010?
Make the answer very short. 0.34. What is the ratio of the Taxes (in $) of Slovak Republic in 2005 to that in 2010?
Offer a very short reply. 0.77. What is the ratio of the Taxes (in $) in South Africa in 2005 to that in 2010?
Make the answer very short. 0.61. What is the ratio of the Taxes (in $) of Egypt, Arab Rep. in 2005 to that in 2011?
Your response must be concise. 0.35. What is the ratio of the Taxes (in $) in Sao Tome and Principe in 2005 to that in 2011?
Offer a very short reply. 0.25. What is the ratio of the Taxes (in $) in Slovak Republic in 2005 to that in 2011?
Ensure brevity in your answer.  0.78. What is the ratio of the Taxes (in $) in South Africa in 2005 to that in 2011?
Your answer should be compact. 0.54. What is the ratio of the Taxes (in $) of Egypt, Arab Rep. in 2006 to that in 2007?
Ensure brevity in your answer.  0.82. What is the ratio of the Taxes (in $) of Sao Tome and Principe in 2006 to that in 2007?
Your answer should be very brief. 0.88. What is the ratio of the Taxes (in $) of Slovak Republic in 2006 to that in 2007?
Provide a succinct answer. 0.79. What is the ratio of the Taxes (in $) of South Africa in 2006 to that in 2007?
Provide a short and direct response. 0.84. What is the ratio of the Taxes (in $) of Egypt, Arab Rep. in 2006 to that in 2008?
Provide a succinct answer. 0.72. What is the ratio of the Taxes (in $) of Sao Tome and Principe in 2006 to that in 2008?
Keep it short and to the point. 0.66. What is the ratio of the Taxes (in $) of Slovak Republic in 2006 to that in 2008?
Provide a short and direct response. 0.72. What is the ratio of the Taxes (in $) in South Africa in 2006 to that in 2008?
Your answer should be compact. 0.73. What is the ratio of the Taxes (in $) in Egypt, Arab Rep. in 2006 to that in 2009?
Offer a terse response. 0.6. What is the ratio of the Taxes (in $) of Sao Tome and Principe in 2006 to that in 2009?
Offer a terse response. 0.5. What is the ratio of the Taxes (in $) of Slovak Republic in 2006 to that in 2009?
Your answer should be compact. 1.03. What is the ratio of the Taxes (in $) of South Africa in 2006 to that in 2009?
Provide a succinct answer. 0.78. What is the ratio of the Taxes (in $) of Egypt, Arab Rep. in 2006 to that in 2010?
Provide a succinct answer. 0.63. What is the ratio of the Taxes (in $) of Sao Tome and Principe in 2006 to that in 2010?
Keep it short and to the point. 0.43. What is the ratio of the Taxes (in $) in Slovak Republic in 2006 to that in 2010?
Offer a terse response. 0.89. What is the ratio of the Taxes (in $) in South Africa in 2006 to that in 2010?
Make the answer very short. 0.74. What is the ratio of the Taxes (in $) of Egypt, Arab Rep. in 2006 to that in 2011?
Provide a short and direct response. 0.54. What is the ratio of the Taxes (in $) of Sao Tome and Principe in 2006 to that in 2011?
Provide a succinct answer. 0.32. What is the ratio of the Taxes (in $) in Slovak Republic in 2006 to that in 2011?
Offer a terse response. 0.9. What is the ratio of the Taxes (in $) in South Africa in 2006 to that in 2011?
Your answer should be very brief. 0.66. What is the ratio of the Taxes (in $) in Egypt, Arab Rep. in 2007 to that in 2008?
Your response must be concise. 0.87. What is the ratio of the Taxes (in $) in Sao Tome and Principe in 2007 to that in 2008?
Ensure brevity in your answer.  0.75. What is the ratio of the Taxes (in $) in Slovak Republic in 2007 to that in 2008?
Provide a succinct answer. 0.92. What is the ratio of the Taxes (in $) of South Africa in 2007 to that in 2008?
Offer a terse response. 0.87. What is the ratio of the Taxes (in $) in Egypt, Arab Rep. in 2007 to that in 2009?
Your answer should be compact. 0.73. What is the ratio of the Taxes (in $) of Sao Tome and Principe in 2007 to that in 2009?
Provide a succinct answer. 0.57. What is the ratio of the Taxes (in $) in Slovak Republic in 2007 to that in 2009?
Keep it short and to the point. 1.32. What is the ratio of the Taxes (in $) in South Africa in 2007 to that in 2009?
Offer a very short reply. 0.92. What is the ratio of the Taxes (in $) of Egypt, Arab Rep. in 2007 to that in 2010?
Make the answer very short. 0.76. What is the ratio of the Taxes (in $) of Sao Tome and Principe in 2007 to that in 2010?
Provide a succinct answer. 0.49. What is the ratio of the Taxes (in $) in Slovak Republic in 2007 to that in 2010?
Your answer should be very brief. 1.13. What is the ratio of the Taxes (in $) in South Africa in 2007 to that in 2010?
Your answer should be very brief. 0.87. What is the ratio of the Taxes (in $) in Egypt, Arab Rep. in 2007 to that in 2011?
Provide a succinct answer. 0.65. What is the ratio of the Taxes (in $) in Sao Tome and Principe in 2007 to that in 2011?
Offer a very short reply. 0.37. What is the ratio of the Taxes (in $) of Slovak Republic in 2007 to that in 2011?
Make the answer very short. 1.15. What is the ratio of the Taxes (in $) in South Africa in 2007 to that in 2011?
Make the answer very short. 0.78. What is the ratio of the Taxes (in $) in Egypt, Arab Rep. in 2008 to that in 2009?
Your response must be concise. 0.84. What is the ratio of the Taxes (in $) of Sao Tome and Principe in 2008 to that in 2009?
Provide a short and direct response. 0.76. What is the ratio of the Taxes (in $) in Slovak Republic in 2008 to that in 2009?
Offer a very short reply. 1.43. What is the ratio of the Taxes (in $) of South Africa in 2008 to that in 2009?
Keep it short and to the point. 1.07. What is the ratio of the Taxes (in $) in Egypt, Arab Rep. in 2008 to that in 2010?
Offer a very short reply. 0.88. What is the ratio of the Taxes (in $) of Sao Tome and Principe in 2008 to that in 2010?
Provide a short and direct response. 0.65. What is the ratio of the Taxes (in $) in Slovak Republic in 2008 to that in 2010?
Ensure brevity in your answer.  1.24. What is the ratio of the Taxes (in $) of South Africa in 2008 to that in 2010?
Provide a short and direct response. 1.01. What is the ratio of the Taxes (in $) of Egypt, Arab Rep. in 2008 to that in 2011?
Your response must be concise. 0.75. What is the ratio of the Taxes (in $) of Sao Tome and Principe in 2008 to that in 2011?
Your response must be concise. 0.48. What is the ratio of the Taxes (in $) of Slovak Republic in 2008 to that in 2011?
Make the answer very short. 1.25. What is the ratio of the Taxes (in $) in South Africa in 2008 to that in 2011?
Offer a very short reply. 0.9. What is the ratio of the Taxes (in $) in Egypt, Arab Rep. in 2009 to that in 2010?
Your answer should be compact. 1.05. What is the ratio of the Taxes (in $) in Sao Tome and Principe in 2009 to that in 2010?
Your answer should be very brief. 0.86. What is the ratio of the Taxes (in $) in Slovak Republic in 2009 to that in 2010?
Make the answer very short. 0.86. What is the ratio of the Taxes (in $) of South Africa in 2009 to that in 2010?
Ensure brevity in your answer.  0.94. What is the ratio of the Taxes (in $) in Egypt, Arab Rep. in 2009 to that in 2011?
Offer a terse response. 0.9. What is the ratio of the Taxes (in $) in Sao Tome and Principe in 2009 to that in 2011?
Your response must be concise. 0.64. What is the ratio of the Taxes (in $) of Slovak Republic in 2009 to that in 2011?
Your response must be concise. 0.87. What is the ratio of the Taxes (in $) of South Africa in 2009 to that in 2011?
Give a very brief answer. 0.84. What is the ratio of the Taxes (in $) in Egypt, Arab Rep. in 2010 to that in 2011?
Offer a terse response. 0.86. What is the ratio of the Taxes (in $) in Sao Tome and Principe in 2010 to that in 2011?
Offer a very short reply. 0.75. What is the ratio of the Taxes (in $) of Slovak Republic in 2010 to that in 2011?
Provide a short and direct response. 1.01. What is the ratio of the Taxes (in $) in South Africa in 2010 to that in 2011?
Your response must be concise. 0.89. What is the difference between the highest and the second highest Taxes (in $) in Egypt, Arab Rep.?
Your answer should be compact. 9.34e+09. What is the difference between the highest and the second highest Taxes (in $) in Sao Tome and Principe?
Offer a very short reply. 5.75e+1. What is the difference between the highest and the second highest Taxes (in $) in Slovak Republic?
Make the answer very short. 2.04e+08. What is the difference between the highest and the second highest Taxes (in $) of South Africa?
Offer a very short reply. 4.31e+1. What is the difference between the highest and the lowest Taxes (in $) of Egypt, Arab Rep.?
Give a very brief answer. 5.80e+1. What is the difference between the highest and the lowest Taxes (in $) of Sao Tome and Principe?
Keep it short and to the point. 1.69e+11. What is the difference between the highest and the lowest Taxes (in $) of Slovak Republic?
Offer a very short reply. 9.21e+08. What is the difference between the highest and the lowest Taxes (in $) in South Africa?
Keep it short and to the point. 1.96e+11. 